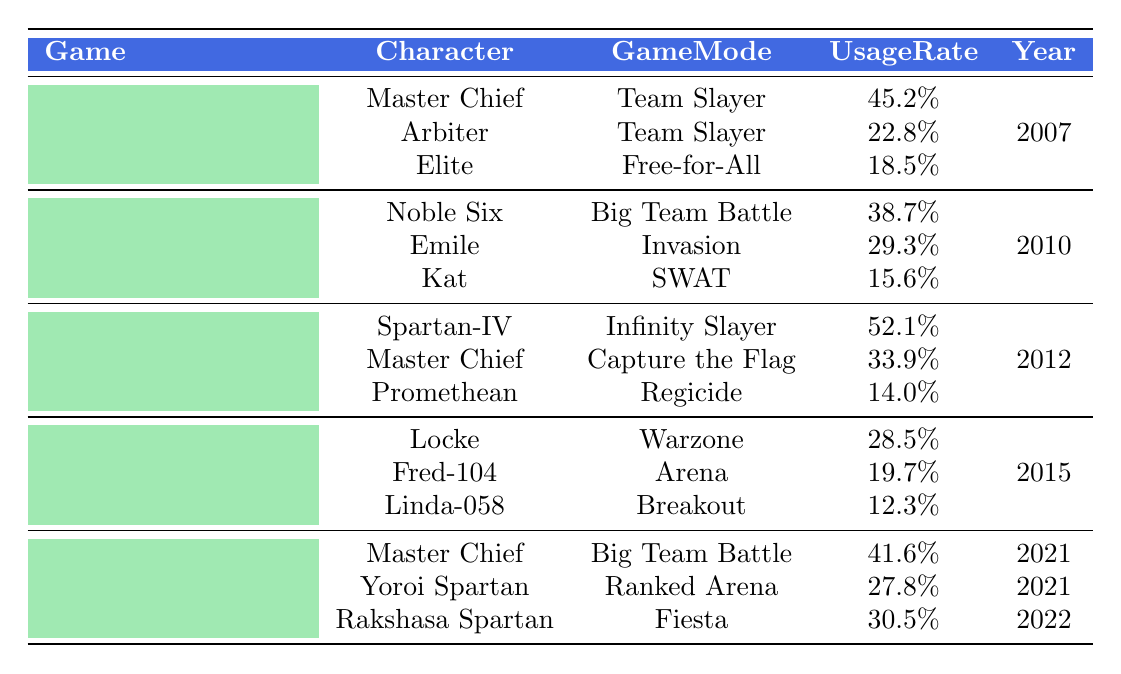What is the highest usage rate among all characters in Halo 4? The highest usage rate in Halo 4 is for the character Spartan-IV, which is 52.1%.
Answer: 52.1% Which character has the lowest usage rate in Halo: Reach? In Halo: Reach, the character with the lowest usage rate is Kat with a usage rate of 15.6%.
Answer: 15.6% Is Master Chief used in Halo 5: Guardians? No, Master Chief is not listed as a character in Halo 5: Guardians; the characters are Locke, Fred-104, and Linda-058.
Answer: No What is the average usage rate of characters in Halo Infinite? The usage rates for Halo Infinite's characters are 41.6%, 27.8%, and 30.5%. The average is calculated as (41.6 + 27.8 + 30.5) / 3 = 33.33%.
Answer: 33.33% Which game mode has the highest overall usage rate for Halo 3? The game mode Team Slayer in Halo 3 has two characters: Master Chief at 45.2% and Arbiter at 22.8%. Summing these gives total usage of 68%. The Free-for-All mode has Elite at 18.5%. Thus, Team Slayer has the highest total usage rate.
Answer: Team Slayer How many characters have a usage rate of 30% or higher in Halo 4? In Halo 4, Spartan-IV has a usage rate of 52.1%, and Master Chief has 33.9%. Summing the characters provides two characters above 30%.
Answer: 2 What percentage of characters in Halo 5: Guardians have usage rates below 20%? In Halo 5: Guardians, Fred-104 has 19.7% and Linda-058 has 12.3%. Only Linda-058 is below 20%, making 1 out of 3 characters, or approximately 33.3%.
Answer: 33.3% Is Noble Six the character with the second highest usage rate in Halo: Reach? Yes, the character Noble Six has a usage rate of 38.7%, which is higher than Emile's 29.3% but less than the highest rate among the mentioned characters.
Answer: Yes 